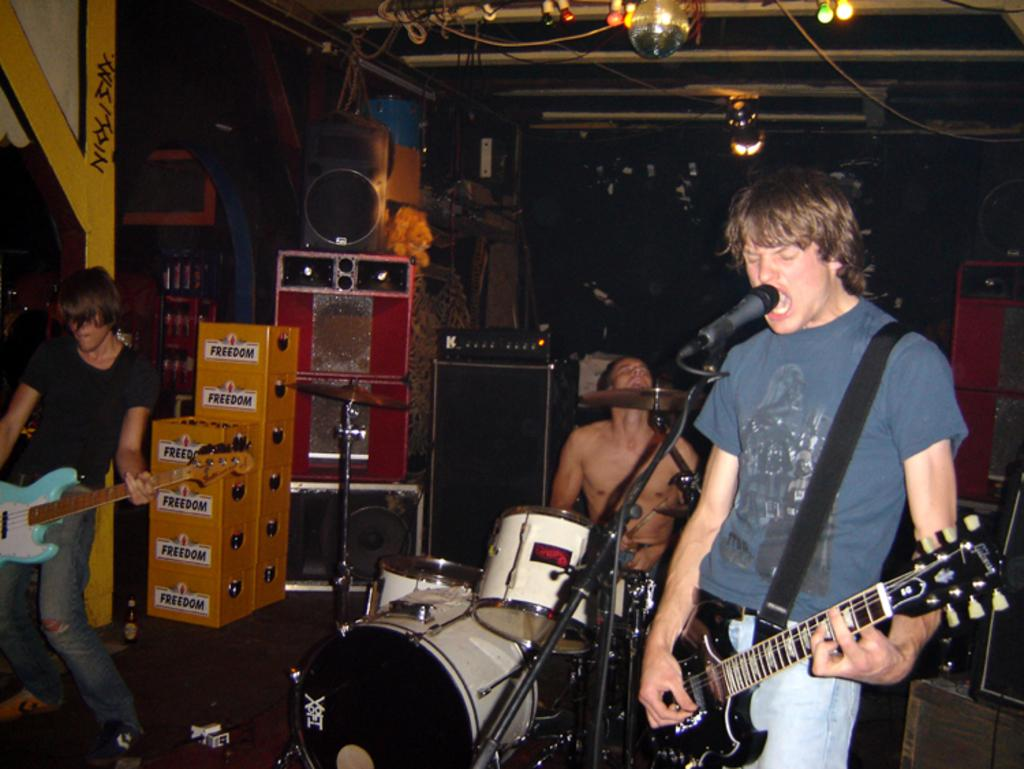What are the two men in the image doing? The two men are standing and playing guitar. What is the third man doing in the image? The third man is standing and singing with a microphone. What instrument is the third man playing? The third man is not playing an instrument; he is singing with a microphone. What is the fourth man doing in the image? There is no fourth man in the image. What type of throat medicine is the man with the microphone using in the image? There is no indication in the image that the man with the microphone is using any throat medicine. 